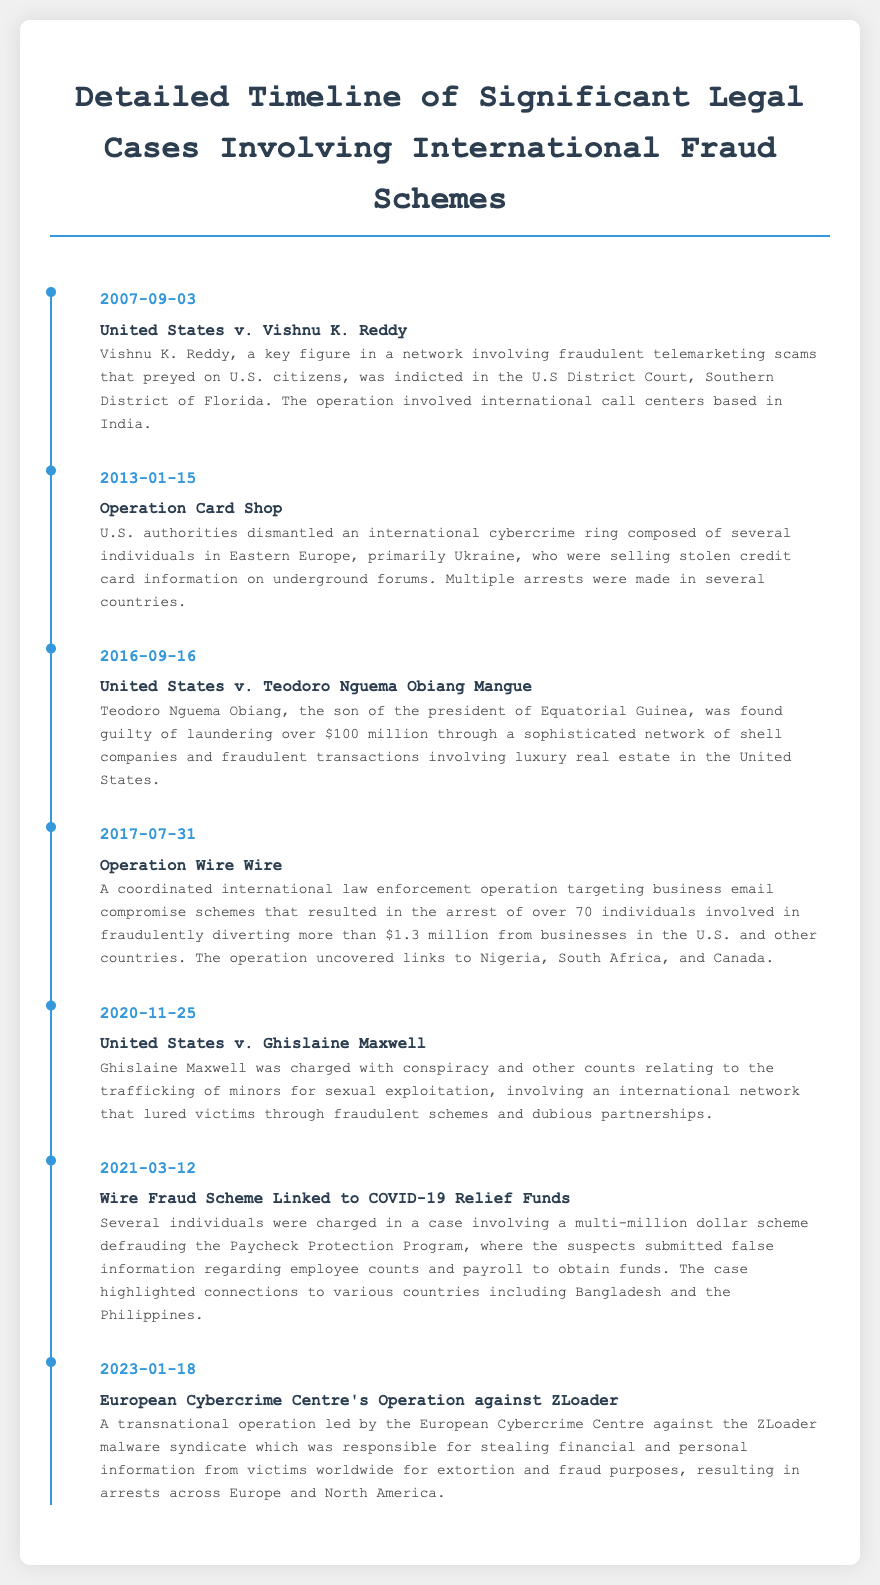What date did Operation Card Shop take place? The date for Operation Card Shop is explicitly mentioned in the document as January 15, 2013.
Answer: January 15, 2013 Who was indicted in the case of United States v. Vishnu K. Reddy? The document states that Vishnu K. Reddy was indicted in this case.
Answer: Vishnu K. Reddy What was Teodoro Nguema Obiang Mangue found guilty of? The description outlines that he was found guilty of laundering over $100 million.
Answer: Laundering over $100 million How many individuals were arrested in Operation Wire Wire? The document states that over 70 individuals were arrested during this operation.
Answer: Over 70 individuals What was the main focus of the Wire Fraud Scheme Linked to COVID-19 Relief Funds? The main focus of this scheme was fraudulent activities involving the Paycheck Protection Program.
Answer: Paycheck Protection Program In which year did the operation against the ZLoader malware syndicate occur? The operation against the ZLoader malware syndicate occurred in 2023, as detailed in the timeline.
Answer: 2023 Which countries were highlighted in the COVID-19 relief funds fraud case? The document mentions connections to Bangladesh and the Philippines regarding this case.
Answer: Bangladesh and the Philippines What type of criminal activity was involved in the case of Ghislaine Maxwell? The case involves the trafficking of minors for sexual exploitation.
Answer: Trafficking of minors What is the total amount fraudulently diverted in Operation Wire Wire? The described amount fraudulently diverted in the operation is more than $1.3 million.
Answer: More than $1.3 million 